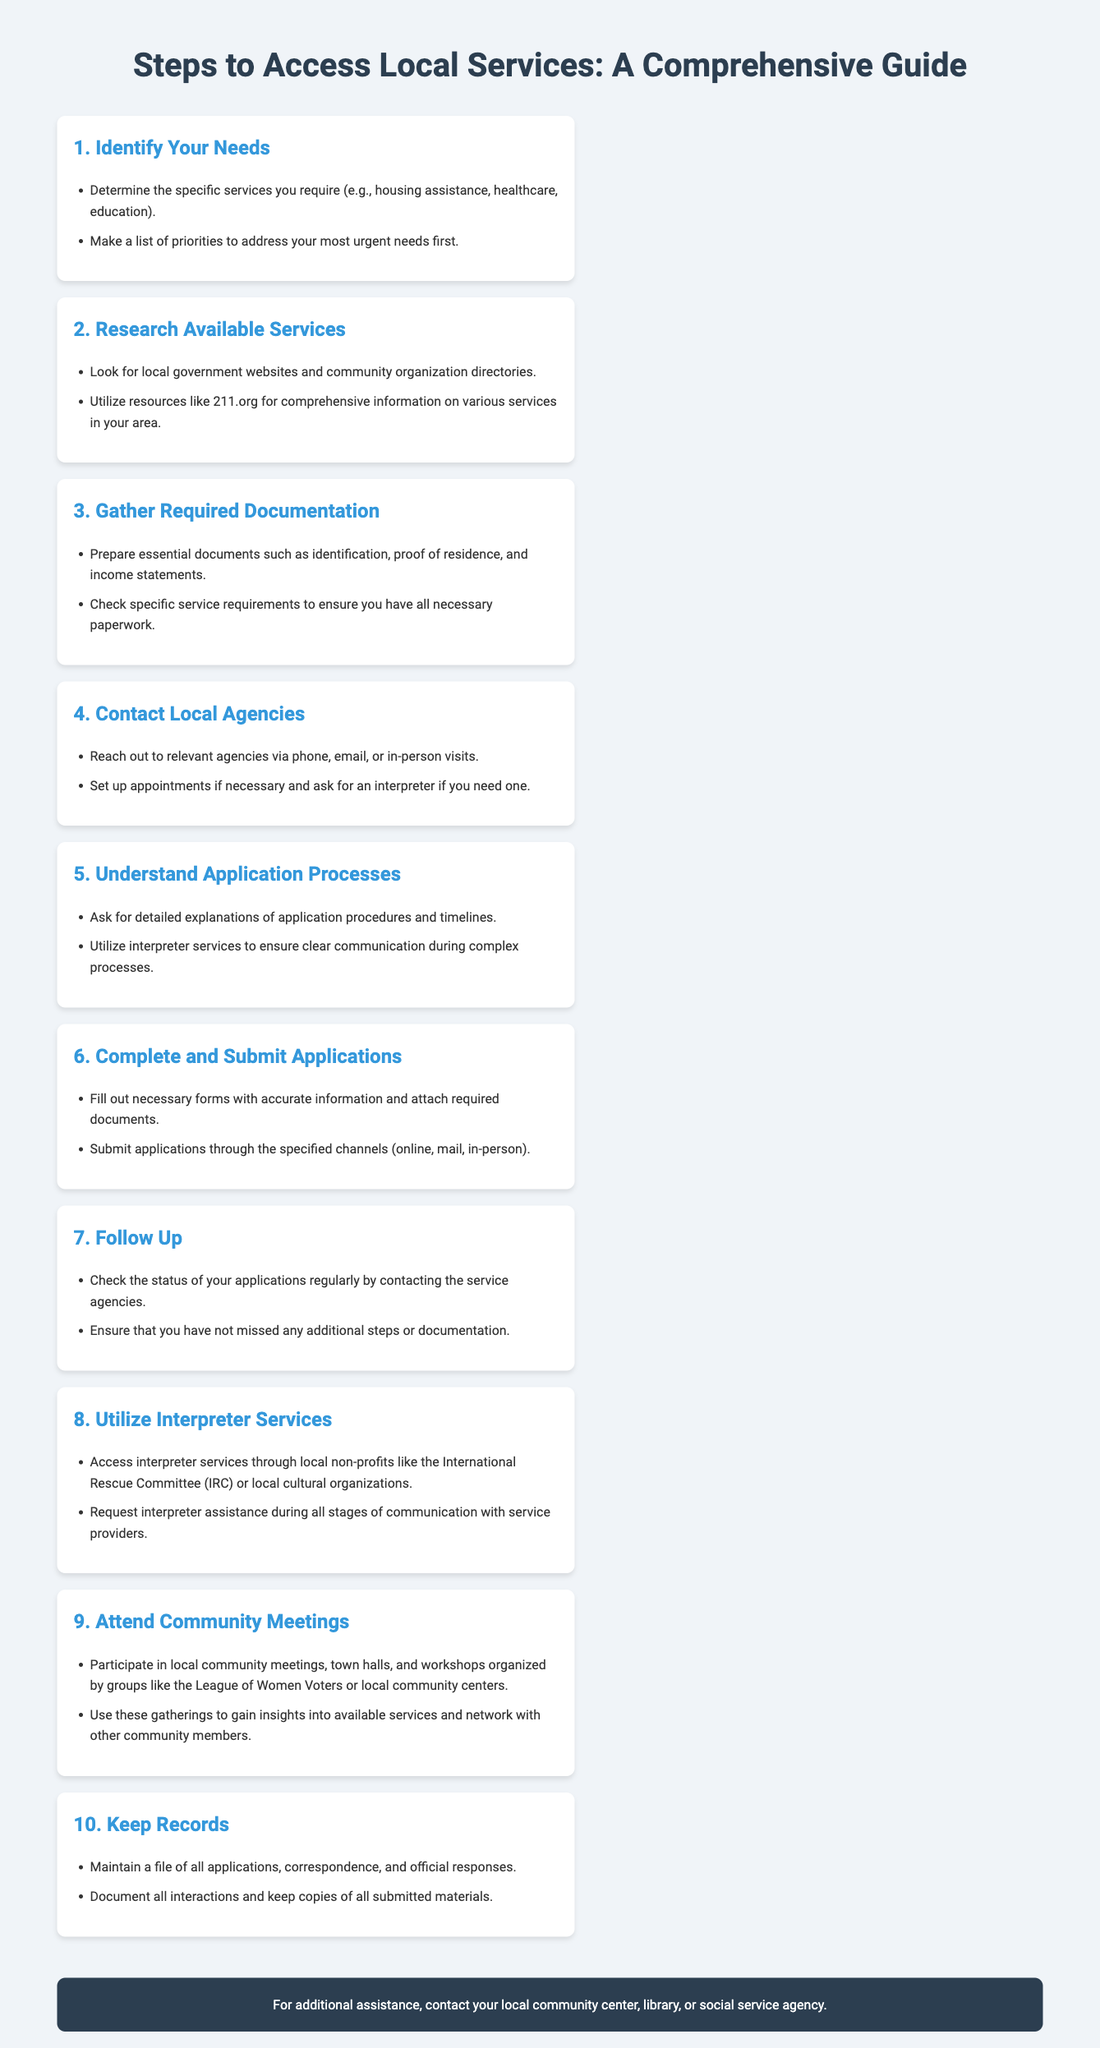What is the first step to access local services? The first step listed in the infographic is to identify your needs.
Answer: Identify Your Needs How many sections are in the infographic? The infographic contains a total of 10 sections.
Answer: 10 What should you prepare for gathering required documentation? The infographic specifies that you should prepare essential documents such as identification, proof of residence, and income statements.
Answer: Identification, proof of residence, income statements Who should you reach out to in step 4? In step 4, it indicates to contact local agencies.
Answer: Local agencies Which service can be utilized to find local services? The infographic mentions that resources like 211.org can be used for this purpose.
Answer: 211.org What is recommended to do after submitting applications? The infographic advises to follow up on the status of your applications.
Answer: Follow up What is the purpose of attending community meetings? The document states that attending these meetings helps to gain insights into available services and network with other community members.
Answer: Gain insights and network Which local organization is mentioned for accessing interpreter services? The infographic mentions the International Rescue Committee (IRC) as a resource for interpreter services.
Answer: International Rescue Committee (IRC) 